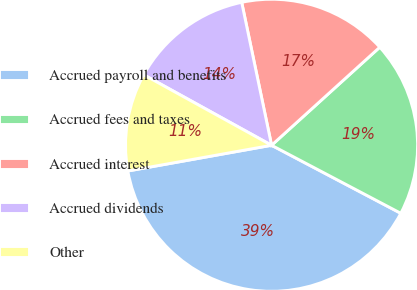Convert chart. <chart><loc_0><loc_0><loc_500><loc_500><pie_chart><fcel>Accrued payroll and benefits<fcel>Accrued fees and taxes<fcel>Accrued interest<fcel>Accrued dividends<fcel>Other<nl><fcel>39.47%<fcel>19.43%<fcel>16.56%<fcel>13.7%<fcel>10.84%<nl></chart> 